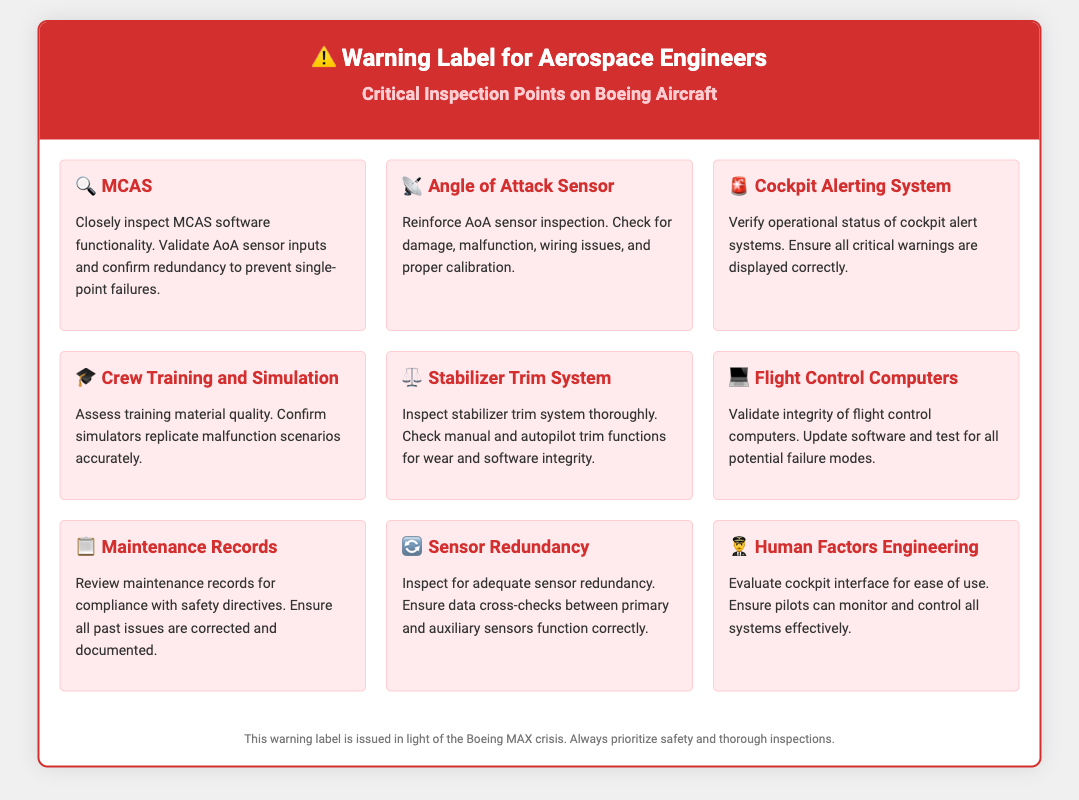What is the title of the document? The title can be found at the top of the document, which is "Warning Label for Aerospace Engineers - Boeing Aircraft."
Answer: Warning Label for Aerospace Engineers - Boeing Aircraft How many critical inspection points are listed? The total number of critical inspection points in the document can be counted within the sections provided; there are 9 points total.
Answer: 9 What icon represents the MCAS warning point? The icon associated with the MCAS warning point is visible next to its title in the document.
Answer: 🔍 Which warning point addresses human factors? This information is presented in the section titled specifically regarding human factors engineering in the document.
Answer: Human Factors Engineering What is the color of the header background? The color of the header background is part of the visual elements and is specified in the design of the document.
Answer: D32F2F How often should maintenance records be reviewed? The document emphasizes the importance of reviewing maintenance records but does not specify a frequency. It is implied to be regularly.
Answer: Regularly What is the main focus of the warning label? The main focus of the warning label can be inferred from its content related to safety inspections on Boeing aircraft.
Answer: Safety inspections What system needs validation of integrity according to the document? This pertains to the flight control systems as mentioned in the relevant section of the document.
Answer: Flight control computers What does the cockpit alerting system verify? The specific purpose of the cockpit alerting system can be understood from the description related to operational status verification.
Answer: Operational status 